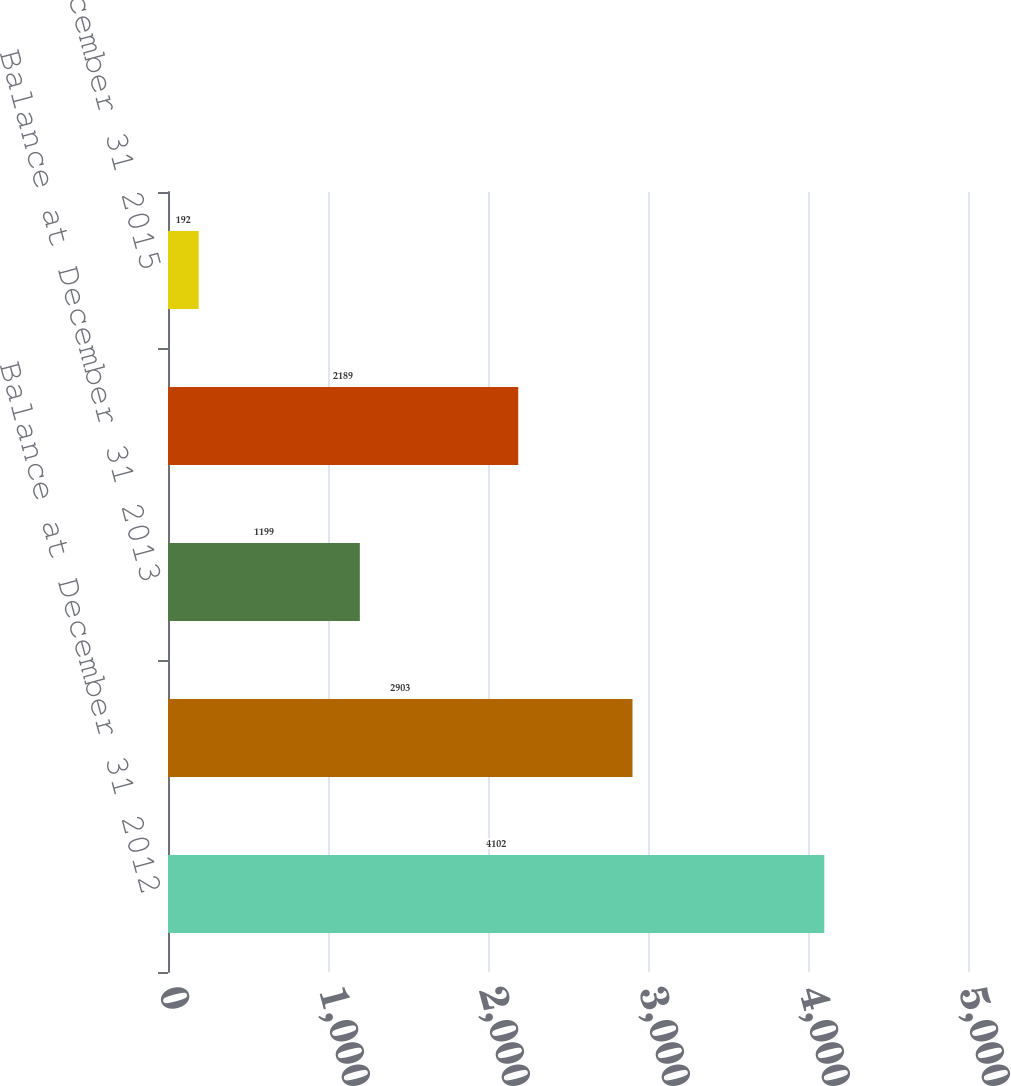Convert chart. <chart><loc_0><loc_0><loc_500><loc_500><bar_chart><fcel>Balance at December 31 2012<fcel>Net change<fcel>Balance at December 31 2013<fcel>Balance at December 31 2014<fcel>Balance at December 31 2015<nl><fcel>4102<fcel>2903<fcel>1199<fcel>2189<fcel>192<nl></chart> 